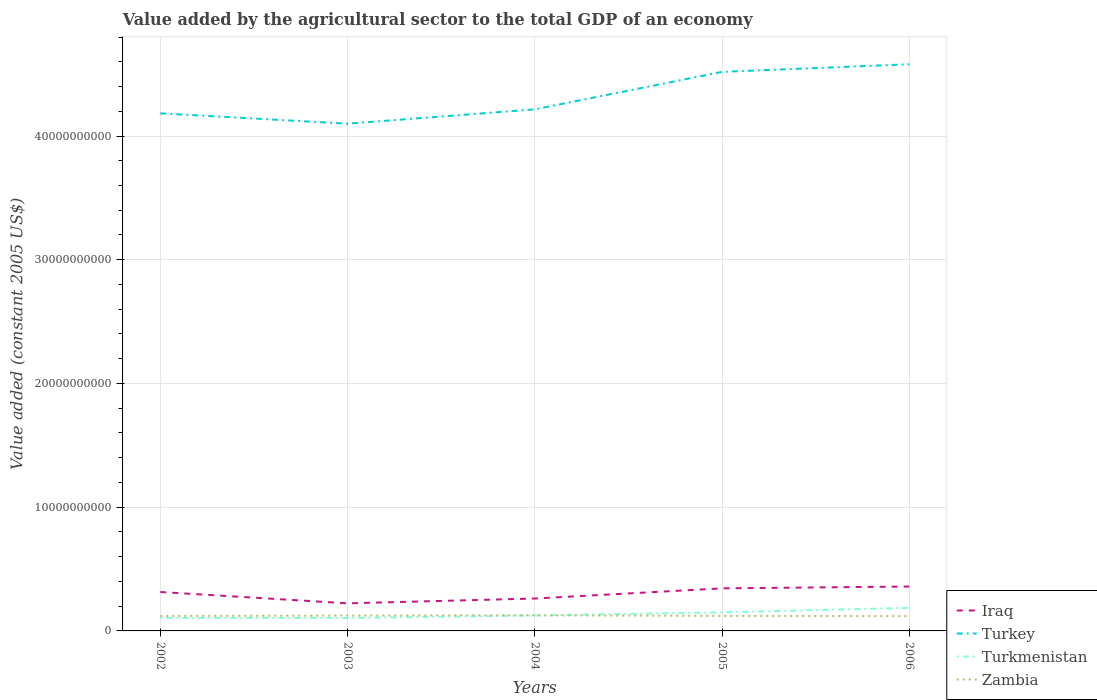Is the number of lines equal to the number of legend labels?
Offer a terse response. Yes. Across all years, what is the maximum value added by the agricultural sector in Iraq?
Your response must be concise. 2.23e+09. What is the total value added by the agricultural sector in Turkey in the graph?
Provide a succinct answer. -4.19e+09. What is the difference between the highest and the second highest value added by the agricultural sector in Turkey?
Keep it short and to the point. 4.80e+09. How many lines are there?
Provide a succinct answer. 4. How many years are there in the graph?
Keep it short and to the point. 5. Are the values on the major ticks of Y-axis written in scientific E-notation?
Offer a very short reply. No. Does the graph contain any zero values?
Your answer should be compact. No. Where does the legend appear in the graph?
Make the answer very short. Bottom right. How many legend labels are there?
Your answer should be compact. 4. What is the title of the graph?
Ensure brevity in your answer.  Value added by the agricultural sector to the total GDP of an economy. Does "Burundi" appear as one of the legend labels in the graph?
Make the answer very short. No. What is the label or title of the Y-axis?
Provide a short and direct response. Value added (constant 2005 US$). What is the Value added (constant 2005 US$) of Iraq in 2002?
Give a very brief answer. 3.15e+09. What is the Value added (constant 2005 US$) of Turkey in 2002?
Give a very brief answer. 4.18e+1. What is the Value added (constant 2005 US$) of Turkmenistan in 2002?
Offer a very short reply. 1.05e+09. What is the Value added (constant 2005 US$) in Zambia in 2002?
Provide a short and direct response. 1.21e+09. What is the Value added (constant 2005 US$) in Iraq in 2003?
Provide a short and direct response. 2.23e+09. What is the Value added (constant 2005 US$) of Turkey in 2003?
Ensure brevity in your answer.  4.10e+1. What is the Value added (constant 2005 US$) of Turkmenistan in 2003?
Offer a very short reply. 1.05e+09. What is the Value added (constant 2005 US$) of Zambia in 2003?
Make the answer very short. 1.24e+09. What is the Value added (constant 2005 US$) in Iraq in 2004?
Give a very brief answer. 2.62e+09. What is the Value added (constant 2005 US$) of Turkey in 2004?
Provide a short and direct response. 4.22e+1. What is the Value added (constant 2005 US$) in Turkmenistan in 2004?
Provide a succinct answer. 1.25e+09. What is the Value added (constant 2005 US$) in Zambia in 2004?
Offer a very short reply. 1.26e+09. What is the Value added (constant 2005 US$) in Iraq in 2005?
Ensure brevity in your answer.  3.44e+09. What is the Value added (constant 2005 US$) of Turkey in 2005?
Your answer should be compact. 4.52e+1. What is the Value added (constant 2005 US$) of Turkmenistan in 2005?
Your answer should be very brief. 1.50e+09. What is the Value added (constant 2005 US$) of Zambia in 2005?
Your answer should be very brief. 1.22e+09. What is the Value added (constant 2005 US$) of Iraq in 2006?
Make the answer very short. 3.59e+09. What is the Value added (constant 2005 US$) of Turkey in 2006?
Give a very brief answer. 4.58e+1. What is the Value added (constant 2005 US$) in Turkmenistan in 2006?
Keep it short and to the point. 1.86e+09. What is the Value added (constant 2005 US$) in Zambia in 2006?
Provide a succinct answer. 1.20e+09. Across all years, what is the maximum Value added (constant 2005 US$) in Iraq?
Ensure brevity in your answer.  3.59e+09. Across all years, what is the maximum Value added (constant 2005 US$) in Turkey?
Ensure brevity in your answer.  4.58e+1. Across all years, what is the maximum Value added (constant 2005 US$) of Turkmenistan?
Provide a succinct answer. 1.86e+09. Across all years, what is the maximum Value added (constant 2005 US$) of Zambia?
Your answer should be very brief. 1.26e+09. Across all years, what is the minimum Value added (constant 2005 US$) of Iraq?
Give a very brief answer. 2.23e+09. Across all years, what is the minimum Value added (constant 2005 US$) in Turkey?
Keep it short and to the point. 4.10e+1. Across all years, what is the minimum Value added (constant 2005 US$) in Turkmenistan?
Give a very brief answer. 1.05e+09. Across all years, what is the minimum Value added (constant 2005 US$) of Zambia?
Keep it short and to the point. 1.20e+09. What is the total Value added (constant 2005 US$) in Iraq in the graph?
Your answer should be compact. 1.50e+1. What is the total Value added (constant 2005 US$) in Turkey in the graph?
Give a very brief answer. 2.16e+11. What is the total Value added (constant 2005 US$) in Turkmenistan in the graph?
Your response must be concise. 6.70e+09. What is the total Value added (constant 2005 US$) of Zambia in the graph?
Make the answer very short. 6.12e+09. What is the difference between the Value added (constant 2005 US$) in Iraq in 2002 and that in 2003?
Make the answer very short. 9.16e+08. What is the difference between the Value added (constant 2005 US$) of Turkey in 2002 and that in 2003?
Ensure brevity in your answer.  8.36e+08. What is the difference between the Value added (constant 2005 US$) of Turkmenistan in 2002 and that in 2003?
Offer a terse response. -1.03e+06. What is the difference between the Value added (constant 2005 US$) of Zambia in 2002 and that in 2003?
Keep it short and to the point. -3.33e+07. What is the difference between the Value added (constant 2005 US$) of Iraq in 2002 and that in 2004?
Offer a terse response. 5.28e+08. What is the difference between the Value added (constant 2005 US$) in Turkey in 2002 and that in 2004?
Offer a terse response. -3.24e+08. What is the difference between the Value added (constant 2005 US$) of Turkmenistan in 2002 and that in 2004?
Offer a very short reply. -2.03e+08. What is the difference between the Value added (constant 2005 US$) of Zambia in 2002 and that in 2004?
Make the answer very short. -5.30e+07. What is the difference between the Value added (constant 2005 US$) in Iraq in 2002 and that in 2005?
Keep it short and to the point. -2.94e+08. What is the difference between the Value added (constant 2005 US$) of Turkey in 2002 and that in 2005?
Offer a very short reply. -3.35e+09. What is the difference between the Value added (constant 2005 US$) of Turkmenistan in 2002 and that in 2005?
Make the answer very short. -4.56e+08. What is the difference between the Value added (constant 2005 US$) in Zambia in 2002 and that in 2005?
Make the answer very short. -8.28e+06. What is the difference between the Value added (constant 2005 US$) in Iraq in 2002 and that in 2006?
Your answer should be very brief. -4.42e+08. What is the difference between the Value added (constant 2005 US$) in Turkey in 2002 and that in 2006?
Offer a terse response. -3.97e+09. What is the difference between the Value added (constant 2005 US$) in Turkmenistan in 2002 and that in 2006?
Give a very brief answer. -8.17e+08. What is the difference between the Value added (constant 2005 US$) of Zambia in 2002 and that in 2006?
Your answer should be very brief. 9.04e+06. What is the difference between the Value added (constant 2005 US$) in Iraq in 2003 and that in 2004?
Provide a short and direct response. -3.89e+08. What is the difference between the Value added (constant 2005 US$) of Turkey in 2003 and that in 2004?
Give a very brief answer. -1.16e+09. What is the difference between the Value added (constant 2005 US$) of Turkmenistan in 2003 and that in 2004?
Ensure brevity in your answer.  -2.02e+08. What is the difference between the Value added (constant 2005 US$) in Zambia in 2003 and that in 2004?
Ensure brevity in your answer.  -1.98e+07. What is the difference between the Value added (constant 2005 US$) in Iraq in 2003 and that in 2005?
Make the answer very short. -1.21e+09. What is the difference between the Value added (constant 2005 US$) in Turkey in 2003 and that in 2005?
Offer a terse response. -4.19e+09. What is the difference between the Value added (constant 2005 US$) in Turkmenistan in 2003 and that in 2005?
Provide a succinct answer. -4.55e+08. What is the difference between the Value added (constant 2005 US$) in Zambia in 2003 and that in 2005?
Your response must be concise. 2.50e+07. What is the difference between the Value added (constant 2005 US$) of Iraq in 2003 and that in 2006?
Provide a succinct answer. -1.36e+09. What is the difference between the Value added (constant 2005 US$) in Turkey in 2003 and that in 2006?
Provide a short and direct response. -4.80e+09. What is the difference between the Value added (constant 2005 US$) in Turkmenistan in 2003 and that in 2006?
Offer a terse response. -8.16e+08. What is the difference between the Value added (constant 2005 US$) in Zambia in 2003 and that in 2006?
Ensure brevity in your answer.  4.23e+07. What is the difference between the Value added (constant 2005 US$) in Iraq in 2004 and that in 2005?
Provide a succinct answer. -8.21e+08. What is the difference between the Value added (constant 2005 US$) in Turkey in 2004 and that in 2005?
Provide a succinct answer. -3.03e+09. What is the difference between the Value added (constant 2005 US$) of Turkmenistan in 2004 and that in 2005?
Give a very brief answer. -2.53e+08. What is the difference between the Value added (constant 2005 US$) of Zambia in 2004 and that in 2005?
Your response must be concise. 4.48e+07. What is the difference between the Value added (constant 2005 US$) of Iraq in 2004 and that in 2006?
Ensure brevity in your answer.  -9.70e+08. What is the difference between the Value added (constant 2005 US$) of Turkey in 2004 and that in 2006?
Provide a short and direct response. -3.64e+09. What is the difference between the Value added (constant 2005 US$) of Turkmenistan in 2004 and that in 2006?
Make the answer very short. -6.14e+08. What is the difference between the Value added (constant 2005 US$) in Zambia in 2004 and that in 2006?
Provide a short and direct response. 6.21e+07. What is the difference between the Value added (constant 2005 US$) in Iraq in 2005 and that in 2006?
Your response must be concise. -1.48e+08. What is the difference between the Value added (constant 2005 US$) of Turkey in 2005 and that in 2006?
Ensure brevity in your answer.  -6.15e+08. What is the difference between the Value added (constant 2005 US$) of Turkmenistan in 2005 and that in 2006?
Provide a short and direct response. -3.60e+08. What is the difference between the Value added (constant 2005 US$) of Zambia in 2005 and that in 2006?
Your answer should be very brief. 1.73e+07. What is the difference between the Value added (constant 2005 US$) of Iraq in 2002 and the Value added (constant 2005 US$) of Turkey in 2003?
Your response must be concise. -3.78e+1. What is the difference between the Value added (constant 2005 US$) of Iraq in 2002 and the Value added (constant 2005 US$) of Turkmenistan in 2003?
Give a very brief answer. 2.10e+09. What is the difference between the Value added (constant 2005 US$) of Iraq in 2002 and the Value added (constant 2005 US$) of Zambia in 2003?
Offer a very short reply. 1.91e+09. What is the difference between the Value added (constant 2005 US$) in Turkey in 2002 and the Value added (constant 2005 US$) in Turkmenistan in 2003?
Give a very brief answer. 4.08e+1. What is the difference between the Value added (constant 2005 US$) of Turkey in 2002 and the Value added (constant 2005 US$) of Zambia in 2003?
Your response must be concise. 4.06e+1. What is the difference between the Value added (constant 2005 US$) in Turkmenistan in 2002 and the Value added (constant 2005 US$) in Zambia in 2003?
Offer a terse response. -1.95e+08. What is the difference between the Value added (constant 2005 US$) in Iraq in 2002 and the Value added (constant 2005 US$) in Turkey in 2004?
Make the answer very short. -3.90e+1. What is the difference between the Value added (constant 2005 US$) of Iraq in 2002 and the Value added (constant 2005 US$) of Turkmenistan in 2004?
Your response must be concise. 1.90e+09. What is the difference between the Value added (constant 2005 US$) of Iraq in 2002 and the Value added (constant 2005 US$) of Zambia in 2004?
Offer a very short reply. 1.89e+09. What is the difference between the Value added (constant 2005 US$) in Turkey in 2002 and the Value added (constant 2005 US$) in Turkmenistan in 2004?
Make the answer very short. 4.06e+1. What is the difference between the Value added (constant 2005 US$) of Turkey in 2002 and the Value added (constant 2005 US$) of Zambia in 2004?
Provide a succinct answer. 4.06e+1. What is the difference between the Value added (constant 2005 US$) in Turkmenistan in 2002 and the Value added (constant 2005 US$) in Zambia in 2004?
Make the answer very short. -2.15e+08. What is the difference between the Value added (constant 2005 US$) in Iraq in 2002 and the Value added (constant 2005 US$) in Turkey in 2005?
Ensure brevity in your answer.  -4.20e+1. What is the difference between the Value added (constant 2005 US$) in Iraq in 2002 and the Value added (constant 2005 US$) in Turkmenistan in 2005?
Ensure brevity in your answer.  1.64e+09. What is the difference between the Value added (constant 2005 US$) in Iraq in 2002 and the Value added (constant 2005 US$) in Zambia in 2005?
Give a very brief answer. 1.93e+09. What is the difference between the Value added (constant 2005 US$) in Turkey in 2002 and the Value added (constant 2005 US$) in Turkmenistan in 2005?
Your response must be concise. 4.03e+1. What is the difference between the Value added (constant 2005 US$) of Turkey in 2002 and the Value added (constant 2005 US$) of Zambia in 2005?
Your answer should be compact. 4.06e+1. What is the difference between the Value added (constant 2005 US$) in Turkmenistan in 2002 and the Value added (constant 2005 US$) in Zambia in 2005?
Give a very brief answer. -1.70e+08. What is the difference between the Value added (constant 2005 US$) of Iraq in 2002 and the Value added (constant 2005 US$) of Turkey in 2006?
Make the answer very short. -4.27e+1. What is the difference between the Value added (constant 2005 US$) in Iraq in 2002 and the Value added (constant 2005 US$) in Turkmenistan in 2006?
Your answer should be very brief. 1.28e+09. What is the difference between the Value added (constant 2005 US$) in Iraq in 2002 and the Value added (constant 2005 US$) in Zambia in 2006?
Make the answer very short. 1.95e+09. What is the difference between the Value added (constant 2005 US$) of Turkey in 2002 and the Value added (constant 2005 US$) of Turkmenistan in 2006?
Give a very brief answer. 4.00e+1. What is the difference between the Value added (constant 2005 US$) in Turkey in 2002 and the Value added (constant 2005 US$) in Zambia in 2006?
Provide a succinct answer. 4.06e+1. What is the difference between the Value added (constant 2005 US$) of Turkmenistan in 2002 and the Value added (constant 2005 US$) of Zambia in 2006?
Offer a very short reply. -1.53e+08. What is the difference between the Value added (constant 2005 US$) of Iraq in 2003 and the Value added (constant 2005 US$) of Turkey in 2004?
Your response must be concise. -3.99e+1. What is the difference between the Value added (constant 2005 US$) of Iraq in 2003 and the Value added (constant 2005 US$) of Turkmenistan in 2004?
Offer a very short reply. 9.82e+08. What is the difference between the Value added (constant 2005 US$) of Iraq in 2003 and the Value added (constant 2005 US$) of Zambia in 2004?
Your response must be concise. 9.70e+08. What is the difference between the Value added (constant 2005 US$) in Turkey in 2003 and the Value added (constant 2005 US$) in Turkmenistan in 2004?
Provide a short and direct response. 3.97e+1. What is the difference between the Value added (constant 2005 US$) of Turkey in 2003 and the Value added (constant 2005 US$) of Zambia in 2004?
Give a very brief answer. 3.97e+1. What is the difference between the Value added (constant 2005 US$) in Turkmenistan in 2003 and the Value added (constant 2005 US$) in Zambia in 2004?
Your answer should be very brief. -2.14e+08. What is the difference between the Value added (constant 2005 US$) in Iraq in 2003 and the Value added (constant 2005 US$) in Turkey in 2005?
Ensure brevity in your answer.  -4.30e+1. What is the difference between the Value added (constant 2005 US$) of Iraq in 2003 and the Value added (constant 2005 US$) of Turkmenistan in 2005?
Provide a succinct answer. 7.28e+08. What is the difference between the Value added (constant 2005 US$) in Iraq in 2003 and the Value added (constant 2005 US$) in Zambia in 2005?
Offer a very short reply. 1.01e+09. What is the difference between the Value added (constant 2005 US$) in Turkey in 2003 and the Value added (constant 2005 US$) in Turkmenistan in 2005?
Make the answer very short. 3.95e+1. What is the difference between the Value added (constant 2005 US$) in Turkey in 2003 and the Value added (constant 2005 US$) in Zambia in 2005?
Make the answer very short. 3.98e+1. What is the difference between the Value added (constant 2005 US$) in Turkmenistan in 2003 and the Value added (constant 2005 US$) in Zambia in 2005?
Offer a terse response. -1.69e+08. What is the difference between the Value added (constant 2005 US$) of Iraq in 2003 and the Value added (constant 2005 US$) of Turkey in 2006?
Ensure brevity in your answer.  -4.36e+1. What is the difference between the Value added (constant 2005 US$) of Iraq in 2003 and the Value added (constant 2005 US$) of Turkmenistan in 2006?
Give a very brief answer. 3.68e+08. What is the difference between the Value added (constant 2005 US$) of Iraq in 2003 and the Value added (constant 2005 US$) of Zambia in 2006?
Your answer should be compact. 1.03e+09. What is the difference between the Value added (constant 2005 US$) of Turkey in 2003 and the Value added (constant 2005 US$) of Turkmenistan in 2006?
Provide a succinct answer. 3.91e+1. What is the difference between the Value added (constant 2005 US$) of Turkey in 2003 and the Value added (constant 2005 US$) of Zambia in 2006?
Provide a short and direct response. 3.98e+1. What is the difference between the Value added (constant 2005 US$) of Turkmenistan in 2003 and the Value added (constant 2005 US$) of Zambia in 2006?
Ensure brevity in your answer.  -1.52e+08. What is the difference between the Value added (constant 2005 US$) of Iraq in 2004 and the Value added (constant 2005 US$) of Turkey in 2005?
Make the answer very short. -4.26e+1. What is the difference between the Value added (constant 2005 US$) of Iraq in 2004 and the Value added (constant 2005 US$) of Turkmenistan in 2005?
Offer a very short reply. 1.12e+09. What is the difference between the Value added (constant 2005 US$) in Iraq in 2004 and the Value added (constant 2005 US$) in Zambia in 2005?
Keep it short and to the point. 1.40e+09. What is the difference between the Value added (constant 2005 US$) of Turkey in 2004 and the Value added (constant 2005 US$) of Turkmenistan in 2005?
Ensure brevity in your answer.  4.07e+1. What is the difference between the Value added (constant 2005 US$) of Turkey in 2004 and the Value added (constant 2005 US$) of Zambia in 2005?
Your answer should be compact. 4.09e+1. What is the difference between the Value added (constant 2005 US$) of Turkmenistan in 2004 and the Value added (constant 2005 US$) of Zambia in 2005?
Your answer should be very brief. 3.29e+07. What is the difference between the Value added (constant 2005 US$) of Iraq in 2004 and the Value added (constant 2005 US$) of Turkey in 2006?
Make the answer very short. -4.32e+1. What is the difference between the Value added (constant 2005 US$) in Iraq in 2004 and the Value added (constant 2005 US$) in Turkmenistan in 2006?
Keep it short and to the point. 7.57e+08. What is the difference between the Value added (constant 2005 US$) of Iraq in 2004 and the Value added (constant 2005 US$) of Zambia in 2006?
Keep it short and to the point. 1.42e+09. What is the difference between the Value added (constant 2005 US$) of Turkey in 2004 and the Value added (constant 2005 US$) of Turkmenistan in 2006?
Your response must be concise. 4.03e+1. What is the difference between the Value added (constant 2005 US$) in Turkey in 2004 and the Value added (constant 2005 US$) in Zambia in 2006?
Make the answer very short. 4.10e+1. What is the difference between the Value added (constant 2005 US$) of Turkmenistan in 2004 and the Value added (constant 2005 US$) of Zambia in 2006?
Your response must be concise. 5.02e+07. What is the difference between the Value added (constant 2005 US$) in Iraq in 2005 and the Value added (constant 2005 US$) in Turkey in 2006?
Your answer should be very brief. -4.24e+1. What is the difference between the Value added (constant 2005 US$) in Iraq in 2005 and the Value added (constant 2005 US$) in Turkmenistan in 2006?
Your answer should be very brief. 1.58e+09. What is the difference between the Value added (constant 2005 US$) of Iraq in 2005 and the Value added (constant 2005 US$) of Zambia in 2006?
Ensure brevity in your answer.  2.24e+09. What is the difference between the Value added (constant 2005 US$) of Turkey in 2005 and the Value added (constant 2005 US$) of Turkmenistan in 2006?
Ensure brevity in your answer.  4.33e+1. What is the difference between the Value added (constant 2005 US$) of Turkey in 2005 and the Value added (constant 2005 US$) of Zambia in 2006?
Provide a succinct answer. 4.40e+1. What is the difference between the Value added (constant 2005 US$) of Turkmenistan in 2005 and the Value added (constant 2005 US$) of Zambia in 2006?
Offer a very short reply. 3.04e+08. What is the average Value added (constant 2005 US$) of Iraq per year?
Provide a succinct answer. 3.01e+09. What is the average Value added (constant 2005 US$) in Turkey per year?
Provide a succinct answer. 4.32e+1. What is the average Value added (constant 2005 US$) in Turkmenistan per year?
Make the answer very short. 1.34e+09. What is the average Value added (constant 2005 US$) of Zambia per year?
Your answer should be very brief. 1.22e+09. In the year 2002, what is the difference between the Value added (constant 2005 US$) of Iraq and Value added (constant 2005 US$) of Turkey?
Keep it short and to the point. -3.87e+1. In the year 2002, what is the difference between the Value added (constant 2005 US$) of Iraq and Value added (constant 2005 US$) of Turkmenistan?
Offer a very short reply. 2.10e+09. In the year 2002, what is the difference between the Value added (constant 2005 US$) of Iraq and Value added (constant 2005 US$) of Zambia?
Give a very brief answer. 1.94e+09. In the year 2002, what is the difference between the Value added (constant 2005 US$) in Turkey and Value added (constant 2005 US$) in Turkmenistan?
Provide a short and direct response. 4.08e+1. In the year 2002, what is the difference between the Value added (constant 2005 US$) of Turkey and Value added (constant 2005 US$) of Zambia?
Provide a succinct answer. 4.06e+1. In the year 2002, what is the difference between the Value added (constant 2005 US$) in Turkmenistan and Value added (constant 2005 US$) in Zambia?
Offer a terse response. -1.62e+08. In the year 2003, what is the difference between the Value added (constant 2005 US$) in Iraq and Value added (constant 2005 US$) in Turkey?
Ensure brevity in your answer.  -3.88e+1. In the year 2003, what is the difference between the Value added (constant 2005 US$) of Iraq and Value added (constant 2005 US$) of Turkmenistan?
Offer a very short reply. 1.18e+09. In the year 2003, what is the difference between the Value added (constant 2005 US$) of Iraq and Value added (constant 2005 US$) of Zambia?
Provide a succinct answer. 9.90e+08. In the year 2003, what is the difference between the Value added (constant 2005 US$) in Turkey and Value added (constant 2005 US$) in Turkmenistan?
Provide a short and direct response. 3.99e+1. In the year 2003, what is the difference between the Value added (constant 2005 US$) of Turkey and Value added (constant 2005 US$) of Zambia?
Provide a short and direct response. 3.98e+1. In the year 2003, what is the difference between the Value added (constant 2005 US$) in Turkmenistan and Value added (constant 2005 US$) in Zambia?
Provide a short and direct response. -1.94e+08. In the year 2004, what is the difference between the Value added (constant 2005 US$) in Iraq and Value added (constant 2005 US$) in Turkey?
Give a very brief answer. -3.95e+1. In the year 2004, what is the difference between the Value added (constant 2005 US$) of Iraq and Value added (constant 2005 US$) of Turkmenistan?
Your answer should be compact. 1.37e+09. In the year 2004, what is the difference between the Value added (constant 2005 US$) of Iraq and Value added (constant 2005 US$) of Zambia?
Provide a short and direct response. 1.36e+09. In the year 2004, what is the difference between the Value added (constant 2005 US$) in Turkey and Value added (constant 2005 US$) in Turkmenistan?
Keep it short and to the point. 4.09e+1. In the year 2004, what is the difference between the Value added (constant 2005 US$) of Turkey and Value added (constant 2005 US$) of Zambia?
Give a very brief answer. 4.09e+1. In the year 2004, what is the difference between the Value added (constant 2005 US$) in Turkmenistan and Value added (constant 2005 US$) in Zambia?
Offer a very short reply. -1.19e+07. In the year 2005, what is the difference between the Value added (constant 2005 US$) of Iraq and Value added (constant 2005 US$) of Turkey?
Keep it short and to the point. -4.17e+1. In the year 2005, what is the difference between the Value added (constant 2005 US$) of Iraq and Value added (constant 2005 US$) of Turkmenistan?
Ensure brevity in your answer.  1.94e+09. In the year 2005, what is the difference between the Value added (constant 2005 US$) in Iraq and Value added (constant 2005 US$) in Zambia?
Your answer should be compact. 2.22e+09. In the year 2005, what is the difference between the Value added (constant 2005 US$) in Turkey and Value added (constant 2005 US$) in Turkmenistan?
Keep it short and to the point. 4.37e+1. In the year 2005, what is the difference between the Value added (constant 2005 US$) of Turkey and Value added (constant 2005 US$) of Zambia?
Ensure brevity in your answer.  4.40e+1. In the year 2005, what is the difference between the Value added (constant 2005 US$) in Turkmenistan and Value added (constant 2005 US$) in Zambia?
Your answer should be very brief. 2.86e+08. In the year 2006, what is the difference between the Value added (constant 2005 US$) in Iraq and Value added (constant 2005 US$) in Turkey?
Your response must be concise. -4.22e+1. In the year 2006, what is the difference between the Value added (constant 2005 US$) of Iraq and Value added (constant 2005 US$) of Turkmenistan?
Provide a short and direct response. 1.73e+09. In the year 2006, what is the difference between the Value added (constant 2005 US$) of Iraq and Value added (constant 2005 US$) of Zambia?
Your answer should be very brief. 2.39e+09. In the year 2006, what is the difference between the Value added (constant 2005 US$) of Turkey and Value added (constant 2005 US$) of Turkmenistan?
Give a very brief answer. 4.39e+1. In the year 2006, what is the difference between the Value added (constant 2005 US$) of Turkey and Value added (constant 2005 US$) of Zambia?
Ensure brevity in your answer.  4.46e+1. In the year 2006, what is the difference between the Value added (constant 2005 US$) in Turkmenistan and Value added (constant 2005 US$) in Zambia?
Keep it short and to the point. 6.64e+08. What is the ratio of the Value added (constant 2005 US$) in Iraq in 2002 to that in 2003?
Ensure brevity in your answer.  1.41. What is the ratio of the Value added (constant 2005 US$) in Turkey in 2002 to that in 2003?
Offer a very short reply. 1.02. What is the ratio of the Value added (constant 2005 US$) in Turkmenistan in 2002 to that in 2003?
Your answer should be compact. 1. What is the ratio of the Value added (constant 2005 US$) in Zambia in 2002 to that in 2003?
Offer a terse response. 0.97. What is the ratio of the Value added (constant 2005 US$) of Iraq in 2002 to that in 2004?
Provide a short and direct response. 1.2. What is the ratio of the Value added (constant 2005 US$) in Turkmenistan in 2002 to that in 2004?
Your answer should be compact. 0.84. What is the ratio of the Value added (constant 2005 US$) in Zambia in 2002 to that in 2004?
Give a very brief answer. 0.96. What is the ratio of the Value added (constant 2005 US$) of Iraq in 2002 to that in 2005?
Offer a very short reply. 0.91. What is the ratio of the Value added (constant 2005 US$) of Turkey in 2002 to that in 2005?
Ensure brevity in your answer.  0.93. What is the ratio of the Value added (constant 2005 US$) in Turkmenistan in 2002 to that in 2005?
Ensure brevity in your answer.  0.7. What is the ratio of the Value added (constant 2005 US$) in Iraq in 2002 to that in 2006?
Offer a very short reply. 0.88. What is the ratio of the Value added (constant 2005 US$) in Turkey in 2002 to that in 2006?
Ensure brevity in your answer.  0.91. What is the ratio of the Value added (constant 2005 US$) in Turkmenistan in 2002 to that in 2006?
Offer a very short reply. 0.56. What is the ratio of the Value added (constant 2005 US$) in Zambia in 2002 to that in 2006?
Your answer should be compact. 1.01. What is the ratio of the Value added (constant 2005 US$) in Iraq in 2003 to that in 2004?
Keep it short and to the point. 0.85. What is the ratio of the Value added (constant 2005 US$) in Turkey in 2003 to that in 2004?
Keep it short and to the point. 0.97. What is the ratio of the Value added (constant 2005 US$) of Turkmenistan in 2003 to that in 2004?
Ensure brevity in your answer.  0.84. What is the ratio of the Value added (constant 2005 US$) of Zambia in 2003 to that in 2004?
Give a very brief answer. 0.98. What is the ratio of the Value added (constant 2005 US$) in Iraq in 2003 to that in 2005?
Offer a terse response. 0.65. What is the ratio of the Value added (constant 2005 US$) in Turkey in 2003 to that in 2005?
Offer a very short reply. 0.91. What is the ratio of the Value added (constant 2005 US$) of Turkmenistan in 2003 to that in 2005?
Ensure brevity in your answer.  0.7. What is the ratio of the Value added (constant 2005 US$) of Zambia in 2003 to that in 2005?
Your answer should be compact. 1.02. What is the ratio of the Value added (constant 2005 US$) in Iraq in 2003 to that in 2006?
Provide a short and direct response. 0.62. What is the ratio of the Value added (constant 2005 US$) in Turkey in 2003 to that in 2006?
Give a very brief answer. 0.9. What is the ratio of the Value added (constant 2005 US$) of Turkmenistan in 2003 to that in 2006?
Ensure brevity in your answer.  0.56. What is the ratio of the Value added (constant 2005 US$) of Zambia in 2003 to that in 2006?
Offer a very short reply. 1.04. What is the ratio of the Value added (constant 2005 US$) in Iraq in 2004 to that in 2005?
Make the answer very short. 0.76. What is the ratio of the Value added (constant 2005 US$) of Turkey in 2004 to that in 2005?
Offer a terse response. 0.93. What is the ratio of the Value added (constant 2005 US$) in Turkmenistan in 2004 to that in 2005?
Your response must be concise. 0.83. What is the ratio of the Value added (constant 2005 US$) in Zambia in 2004 to that in 2005?
Offer a very short reply. 1.04. What is the ratio of the Value added (constant 2005 US$) of Iraq in 2004 to that in 2006?
Provide a succinct answer. 0.73. What is the ratio of the Value added (constant 2005 US$) in Turkey in 2004 to that in 2006?
Your answer should be compact. 0.92. What is the ratio of the Value added (constant 2005 US$) of Turkmenistan in 2004 to that in 2006?
Keep it short and to the point. 0.67. What is the ratio of the Value added (constant 2005 US$) of Zambia in 2004 to that in 2006?
Your answer should be very brief. 1.05. What is the ratio of the Value added (constant 2005 US$) in Iraq in 2005 to that in 2006?
Keep it short and to the point. 0.96. What is the ratio of the Value added (constant 2005 US$) in Turkey in 2005 to that in 2006?
Your answer should be compact. 0.99. What is the ratio of the Value added (constant 2005 US$) of Turkmenistan in 2005 to that in 2006?
Offer a very short reply. 0.81. What is the ratio of the Value added (constant 2005 US$) in Zambia in 2005 to that in 2006?
Ensure brevity in your answer.  1.01. What is the difference between the highest and the second highest Value added (constant 2005 US$) in Iraq?
Your answer should be compact. 1.48e+08. What is the difference between the highest and the second highest Value added (constant 2005 US$) of Turkey?
Provide a succinct answer. 6.15e+08. What is the difference between the highest and the second highest Value added (constant 2005 US$) of Turkmenistan?
Make the answer very short. 3.60e+08. What is the difference between the highest and the second highest Value added (constant 2005 US$) in Zambia?
Your response must be concise. 1.98e+07. What is the difference between the highest and the lowest Value added (constant 2005 US$) of Iraq?
Keep it short and to the point. 1.36e+09. What is the difference between the highest and the lowest Value added (constant 2005 US$) in Turkey?
Give a very brief answer. 4.80e+09. What is the difference between the highest and the lowest Value added (constant 2005 US$) of Turkmenistan?
Offer a terse response. 8.17e+08. What is the difference between the highest and the lowest Value added (constant 2005 US$) of Zambia?
Offer a very short reply. 6.21e+07. 